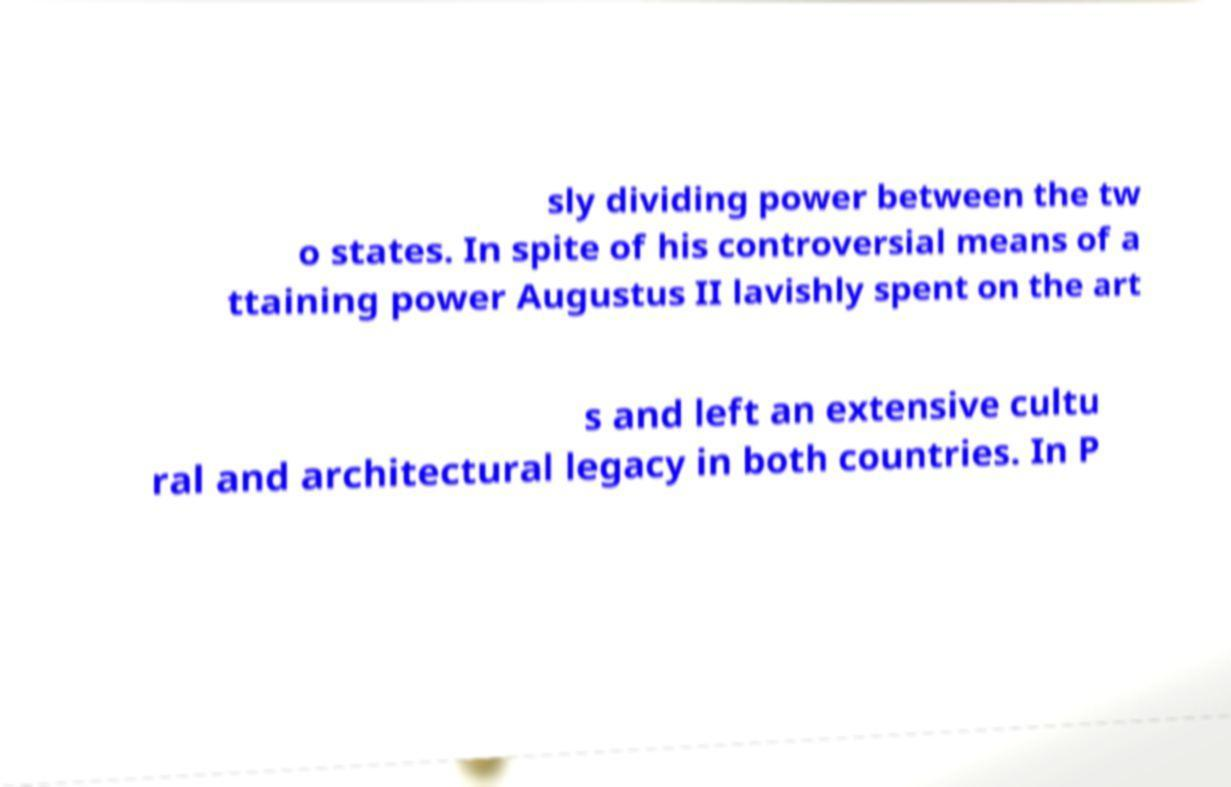There's text embedded in this image that I need extracted. Can you transcribe it verbatim? sly dividing power between the tw o states. In spite of his controversial means of a ttaining power Augustus II lavishly spent on the art s and left an extensive cultu ral and architectural legacy in both countries. In P 